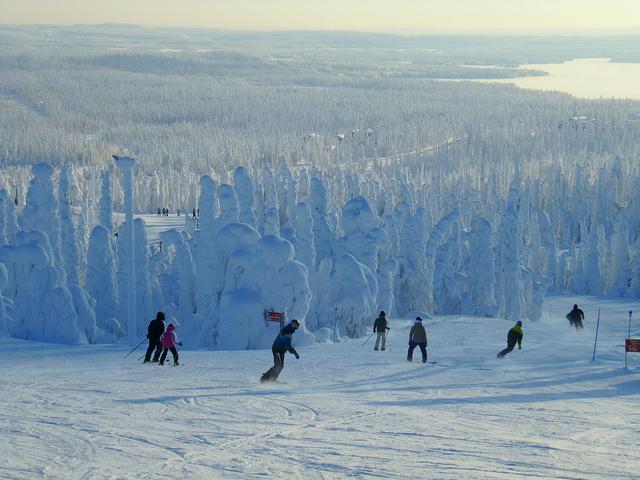What's the ground made of?
Be succinct. Snow. How many people are in this picture?
Quick response, please. 7. Are all these people doing the same activity?
Concise answer only. Yes. Is this daytime?
Concise answer only. Yes. How many men are in the line?
Give a very brief answer. 6. 